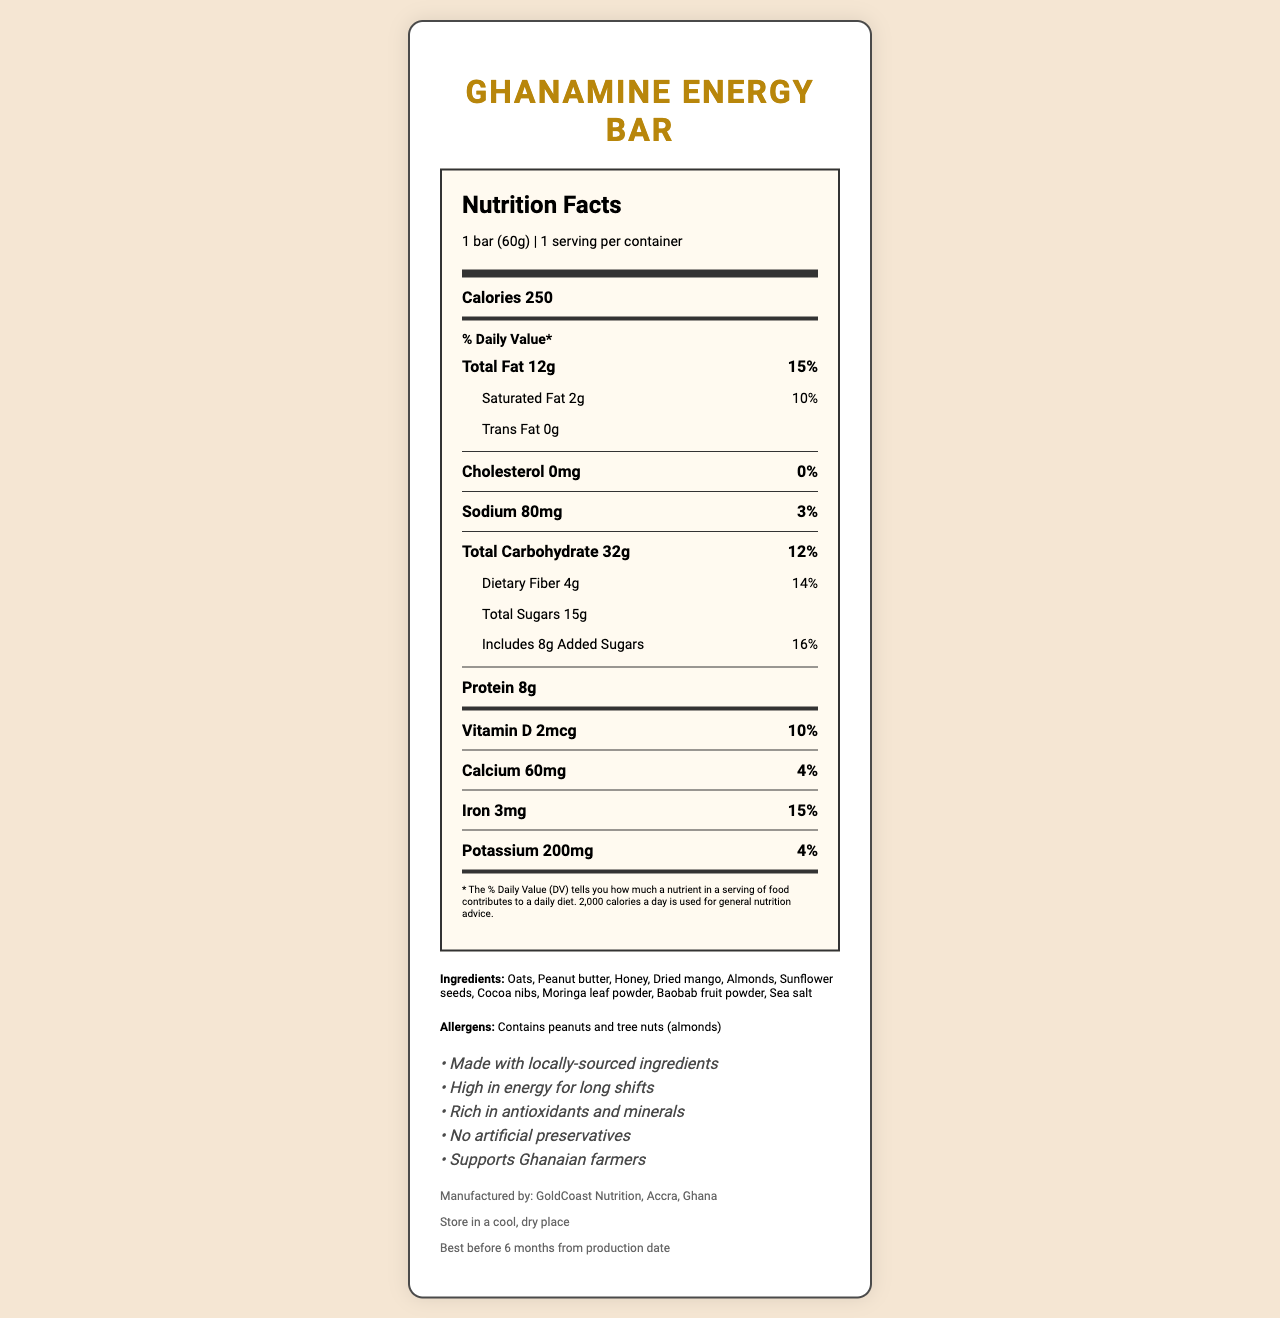what is the serving size of the GhanaMine Energy Bar? The serving size is listed as "1 bar (60g)" on the nutrition label.
Answer: 1 bar (60g) how many calories are there per serving? The nutrition label specifies that there are 250 calories per serving.
Answer: 250 how much dietary fiber does the GhanaMine Energy Bar contain per serving? The label indicates that there are 4 grams of dietary fiber per serving.
Answer: 4g what percentage of the daily value of iron does the GhanaMine Energy Bar provide? The nutrition label shows that the bar provides 15% of the daily value for iron.
Answer: 15% what are the first three ingredients listed for the GhanaMine Energy Bar? The first three ingredients listed are Oats, Peanut butter, and Honey.
Answer: Oats, Peanut butter, Honey how much saturated fat is in each GhanaMine Energy Bar? The amount of saturated fat is listed as 2 grams on the nutrition facts label.
Answer: 2g what company manufactures the GhanaMine Energy Bar? It is stated in the footer that the bar is manufactured by GoldCoast Nutrition, Accra, Ghana.
Answer: GoldCoast Nutrition, Accra, Ghana does the GhanaMine Energy Bar contain any tree nuts? A. Yes B. No The allergen section states that the product contains peanuts and tree nuts (almonds).
Answer: A. Yes how much added sugar is in one bar of the GhanaMine Energy Bar? A. 5g B. 8g C. 10g D. 15g The nutrition label shows that there are 8 grams of added sugars in one bar.
Answer: B. 8g how should the GhanaMine Energy Bar be stored? A. In the refrigerator B. At room temperature C. In a cool, dry place D. In a freezer The storage instructions specify that the product should be stored in a cool, dry place.
Answer: C. In a cool, dry place does the GhanaMine Energy Bar contain any cholesterol? Yes/No The nutrition label shows that there is 0mg cholesterol, indicating it contains no cholesterol.
Answer: No summarize the main claims made about the GhanaMine Energy Bar. The claims section lists the benefits and unique selling points of the product which include local sourcing, energy content, antioxidant and mineral richness, absence of artificial preservatives, and support for local farmers.
Answer: The GhanaMine Energy Bar is made with locally-sourced ingredients, high in energy for long shifts, rich in antioxidants and minerals, contains no artificial preservatives, and supports Ghanaian farmers. what is the percentage of daily value for calcium in the GhanaMine Energy Bar? The nutrition label indicates that the bar provides 4% of the daily value for calcium.
Answer: 4% what is the expiration date of the GhanaMine Energy Bar? The footer of the label specifies that the bar should be consumed within 6 months from the production date.
Answer: Best before 6 months from production date where should you look to find the exact production date of the GhanaMine Energy Bar? The document does not provide the exact production date, only the expiration time frame.
Answer: Cannot be determined what gives the GhanaMine Energy Bar its energy-boosting properties? Based on the ingredients list, oats, honey, and peanut butter are likely contributors to the energy-boosting properties due to their carbohydrate and protein content.
Answer: Oats, Honey, and Peanut Butter 